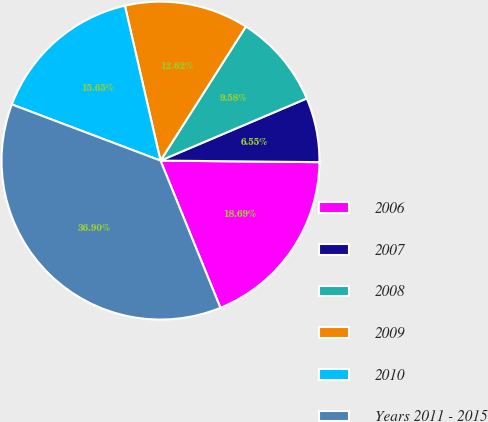Convert chart to OTSL. <chart><loc_0><loc_0><loc_500><loc_500><pie_chart><fcel>2006<fcel>2007<fcel>2008<fcel>2009<fcel>2010<fcel>Years 2011 - 2015<nl><fcel>18.69%<fcel>6.55%<fcel>9.58%<fcel>12.62%<fcel>15.65%<fcel>36.9%<nl></chart> 